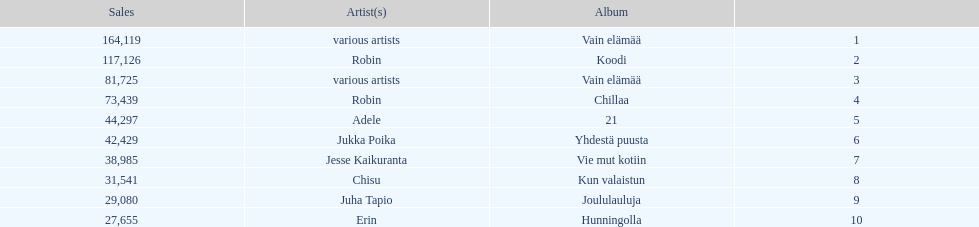Does adele or chisu have the highest number of sales? Adele. 